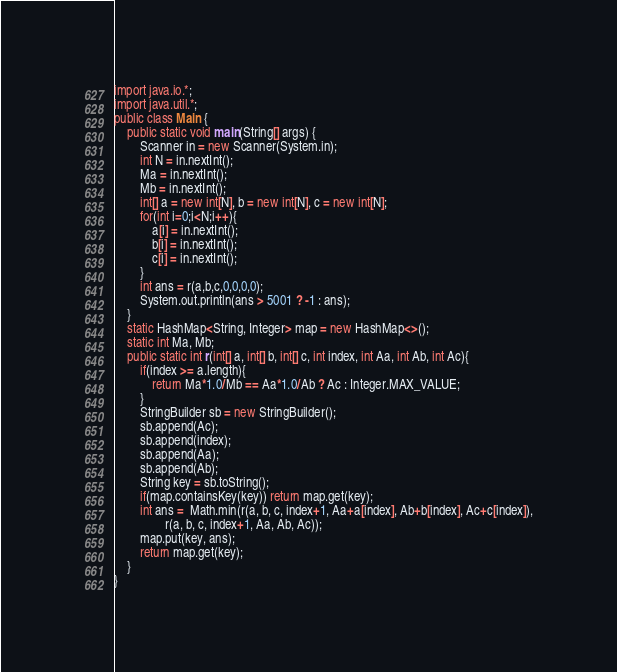Convert code to text. <code><loc_0><loc_0><loc_500><loc_500><_Java_>import java.io.*;
import java.util.*;
public class Main {
	public static void main(String[] args) {
		Scanner in = new Scanner(System.in);
		int N = in.nextInt();
		Ma = in.nextInt();
		Mb = in.nextInt();
		int[] a = new int[N], b = new int[N], c = new int[N];
		for(int i=0;i<N;i++){
			a[i] = in.nextInt();
			b[i] = in.nextInt();
			c[i] = in.nextInt();
		}
		int ans = r(a,b,c,0,0,0,0);
		System.out.println(ans > 5001 ? -1 : ans);
	}
	static HashMap<String, Integer> map = new HashMap<>();
	static int Ma, Mb;
	public static int r(int[] a, int[] b, int[] c, int index, int Aa, int Ab, int Ac){
		if(index >= a.length){
			return Ma*1.0/Mb == Aa*1.0/Ab ? Ac : Integer.MAX_VALUE;
		}
		StringBuilder sb = new StringBuilder();
		sb.append(Ac);
		sb.append(index);
		sb.append(Aa);
		sb.append(Ab);
		String key = sb.toString();
		if(map.containsKey(key)) return map.get(key);
		int ans =  Math.min(r(a, b, c, index+1, Aa+a[index], Ab+b[index], Ac+c[index]),
				r(a, b, c, index+1, Aa, Ab, Ac));
		map.put(key, ans);
		return map.get(key);
	}
}
</code> 